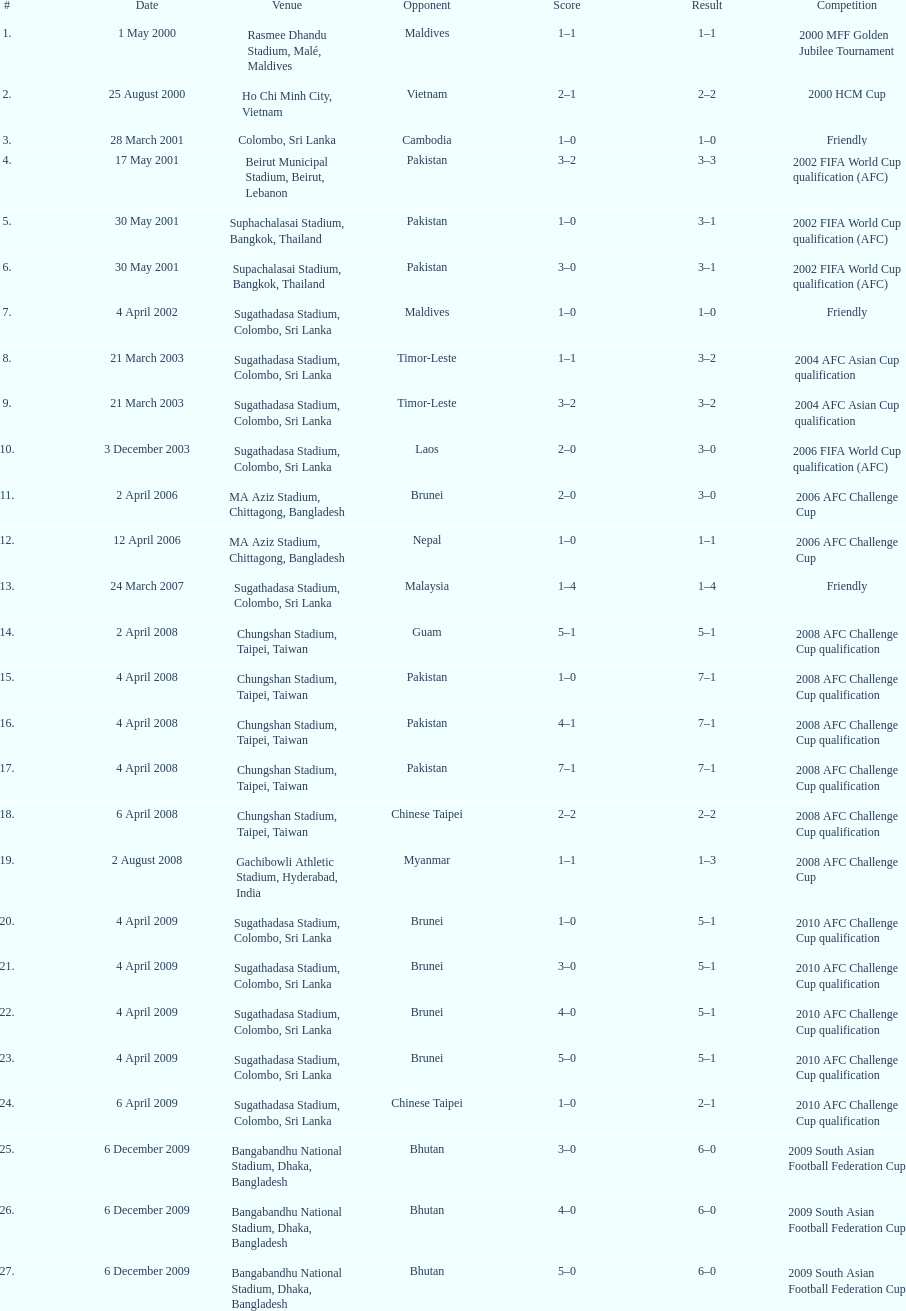What is the number of games played against vietnam? 1. 